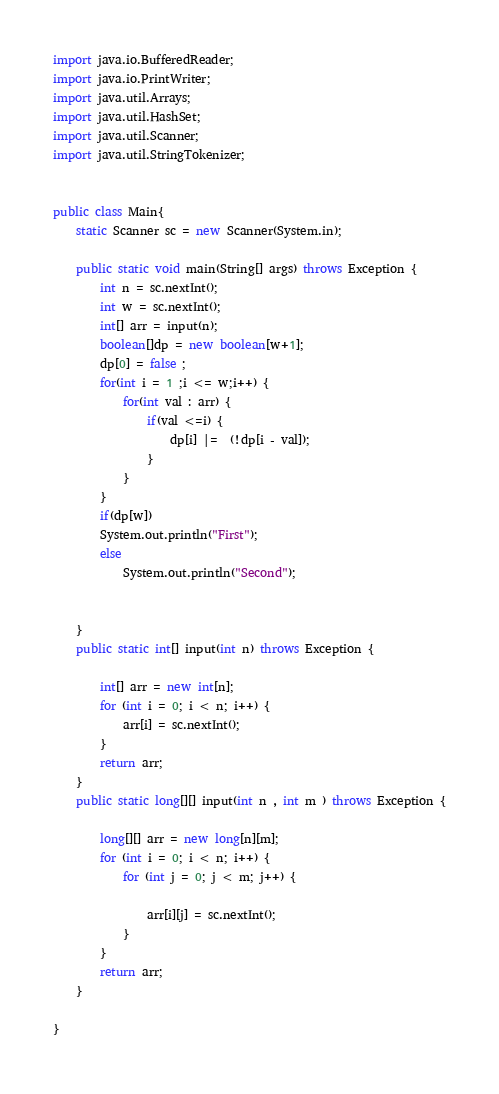<code> <loc_0><loc_0><loc_500><loc_500><_Java_>
import java.io.BufferedReader;
import java.io.PrintWriter;
import java.util.Arrays;
import java.util.HashSet;
import java.util.Scanner;
import java.util.StringTokenizer;


public class Main{
	static Scanner sc = new Scanner(System.in);

	public static void main(String[] args) throws Exception {
		int n = sc.nextInt();
		int w = sc.nextInt();
		int[] arr = input(n);
		boolean[]dp = new boolean[w+1];
		dp[0] = false ;
		for(int i = 1 ;i <= w;i++) {
			for(int val : arr) {
				if(val <=i) {
					dp[i] |=  (!dp[i - val]);
				}
			}
		}
		if(dp[w])
		System.out.println("First");
		else
			System.out.println("Second");

		
	}
	public static int[] input(int n) throws Exception {

		int[] arr = new int[n];
		for (int i = 0; i < n; i++) {
			arr[i] = sc.nextInt();
		}
		return arr;
	}
	public static long[][] input(int n , int m ) throws Exception {

		long[][] arr = new long[n][m];
		for (int i = 0; i < n; i++) {
			for (int j = 0; j < m; j++) {

				arr[i][j] = sc.nextInt();
			}
		}
		return arr;
	}

}
</code> 